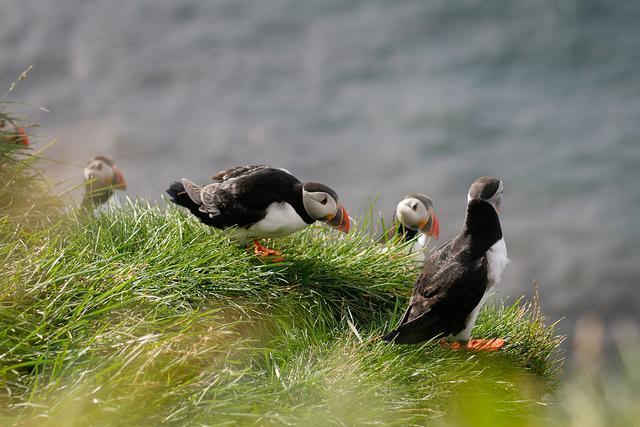How many breaks are visible?
Give a very brief answer. 4. How many birds are there?
Give a very brief answer. 3. 